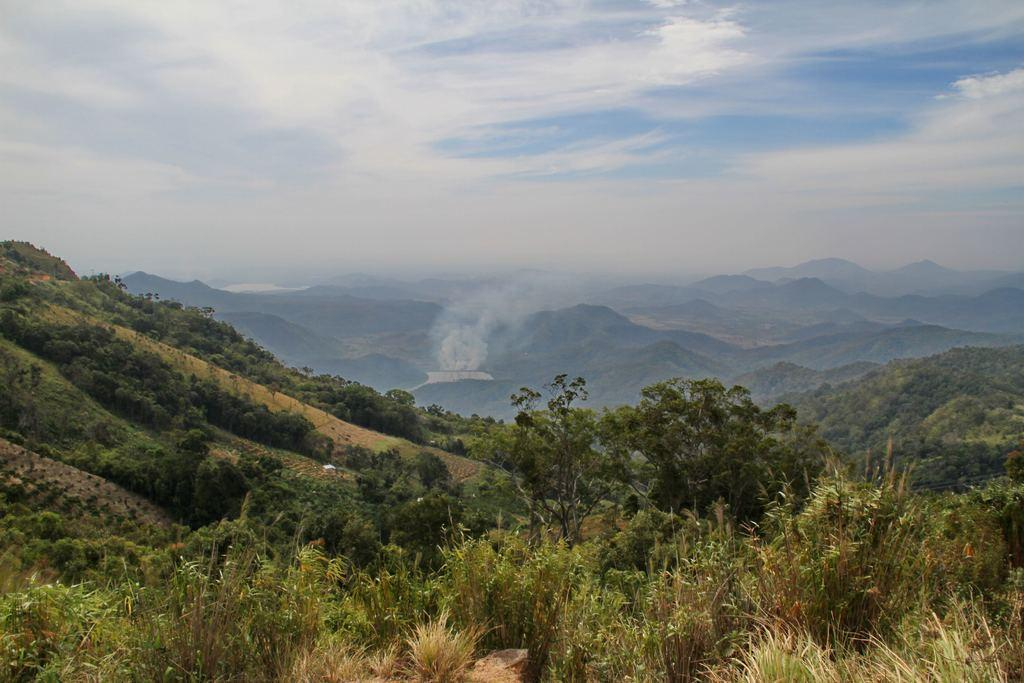What type of natural landform can be seen in the image? There are mountains in the image. What type of vegetation is present in the image? There are trees and grass in the image. What is visible at the top of the image? The sky is visible at the top of the image. What can be seen in the sky? Clouds are present in the sky. What type of boot is being worn by the mountain in the image? There are no boots present in the image, as the subject is a natural landform and not a person or object that could wear boots. 